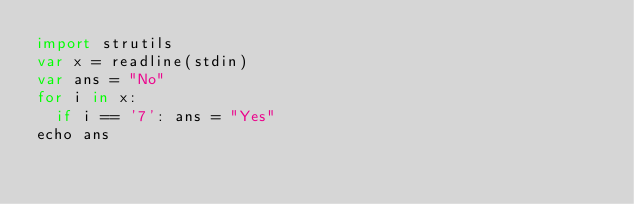<code> <loc_0><loc_0><loc_500><loc_500><_Nim_>import strutils
var x = readline(stdin)
var ans = "No"
for i in x:
  if i == '7': ans = "Yes"
echo ans
    </code> 